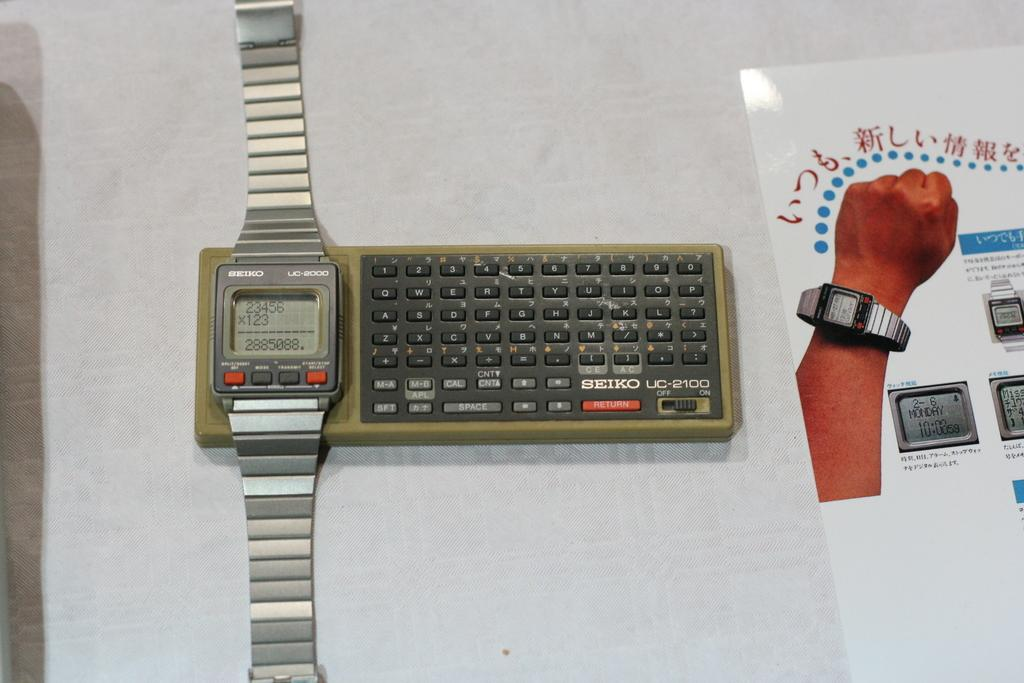<image>
Provide a brief description of the given image. Seiko brand watch on top of a key board. 